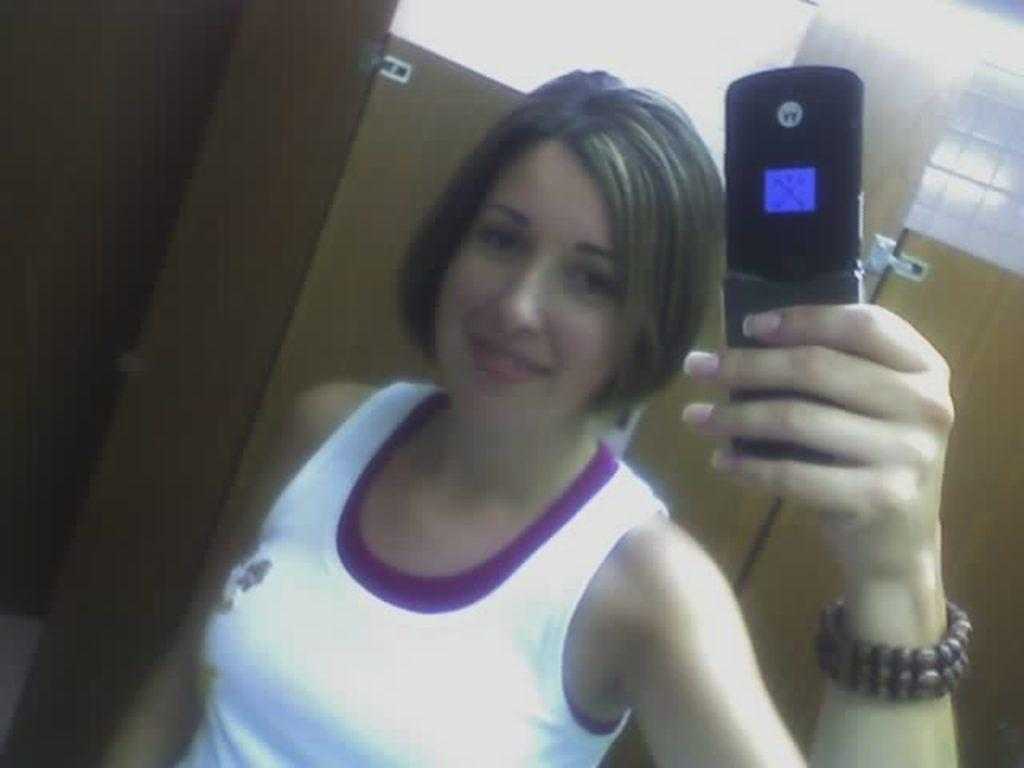Who is the main subject in the image? There is a lady in the image. What is the lady holding in the image? The lady is holding a phone. What can be seen in the background of the image? There is a door visible in the background of the image. What level of medical expertise does the doctor in the image possess? There is no doctor present in the image; it features a lady holding a phone. How does the lady walk in the image? The lady is not walking in the image; she is holding a phone and standing still. 